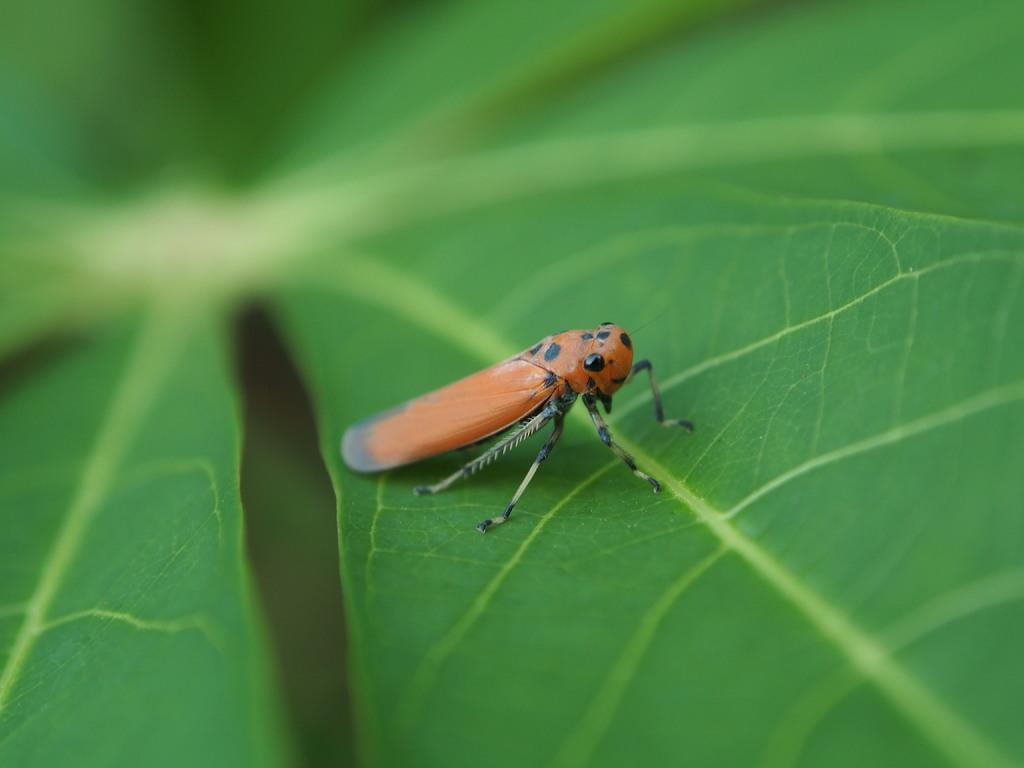Can you describe this image briefly? In this image in the foreground there is a leaf, on the leaf there is an insect and there is a blurry background. 